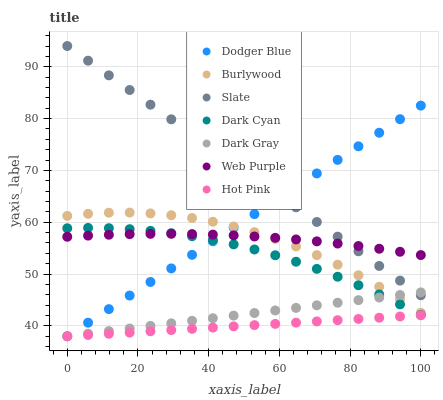Does Hot Pink have the minimum area under the curve?
Answer yes or no. Yes. Does Slate have the maximum area under the curve?
Answer yes or no. Yes. Does Slate have the minimum area under the curve?
Answer yes or no. No. Does Hot Pink have the maximum area under the curve?
Answer yes or no. No. Is Dark Gray the smoothest?
Answer yes or no. Yes. Is Burlywood the roughest?
Answer yes or no. Yes. Is Slate the smoothest?
Answer yes or no. No. Is Slate the roughest?
Answer yes or no. No. Does Hot Pink have the lowest value?
Answer yes or no. Yes. Does Slate have the lowest value?
Answer yes or no. No. Does Slate have the highest value?
Answer yes or no. Yes. Does Hot Pink have the highest value?
Answer yes or no. No. Is Dark Cyan less than Slate?
Answer yes or no. Yes. Is Slate greater than Hot Pink?
Answer yes or no. Yes. Does Burlywood intersect Dark Gray?
Answer yes or no. Yes. Is Burlywood less than Dark Gray?
Answer yes or no. No. Is Burlywood greater than Dark Gray?
Answer yes or no. No. Does Dark Cyan intersect Slate?
Answer yes or no. No. 